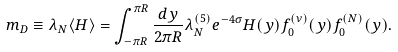Convert formula to latex. <formula><loc_0><loc_0><loc_500><loc_500>m _ { D } \equiv \lambda _ { N } \langle H \rangle = \int _ { - \pi R } ^ { \pi R } \frac { d y } { 2 \pi R } \lambda ^ { ( 5 ) } _ { N } e ^ { - 4 \sigma } H ( y ) f _ { 0 } ^ { ( \nu ) } ( y ) f _ { 0 } ^ { ( N ) } ( y ) .</formula> 